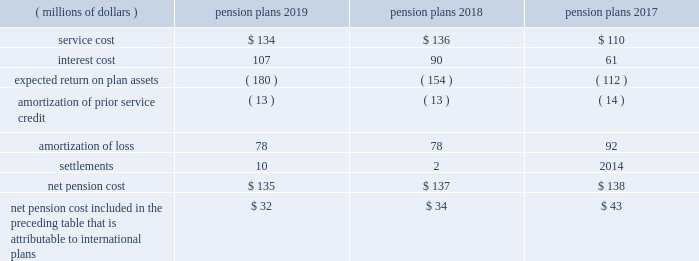Note 9 2014 benefit plans the company has defined benefit pension plans covering certain employees in the united states and certain international locations .
Postretirement healthcare and life insurance benefits provided to qualifying domestic retirees as well as other postretirement benefit plans in international countries are not material .
The measurement date used for the company 2019s employee benefit plans is september 30 .
Effective january 1 , 2018 , the legacy u.s .
Pension plan was frozen to limit the participation of employees who are hired or re-hired by the company , or who transfer employment to the company , on or after january 1 , net pension cost for the years ended september 30 included the following components: .
Net pension cost included in the preceding table that is attributable to international plans $ 32 $ 34 $ 43 the amounts provided above for amortization of prior service credit and amortization of loss represent the reclassifications of prior service credits and net actuarial losses that were recognized in accumulated other comprehensive income ( loss ) in prior periods .
The settlement losses recorded in 2019 and 2018 primarily included lump sum benefit payments associated with the company 2019s u.s .
Supplemental pension plan .
The company recognizes pension settlements when payments from the supplemental plan exceed the sum of service and interest cost components of net periodic pension cost associated with this plan for the fiscal year .
As further discussed in note 2 , upon adopting an accounting standard update on october 1 , 2018 , all components of the company 2019s net periodic pension and postretirement benefit costs , aside from service cost , are recorded to other income ( expense ) , net on its consolidated statements of income , for all periods presented .
Notes to consolidated financial statements 2014 ( continued ) becton , dickinson and company .
What is the average net pension cost for 2017-2019 , in millions? 
Computations: (((135 + 137) + 138) / 3)
Answer: 136.66667. 